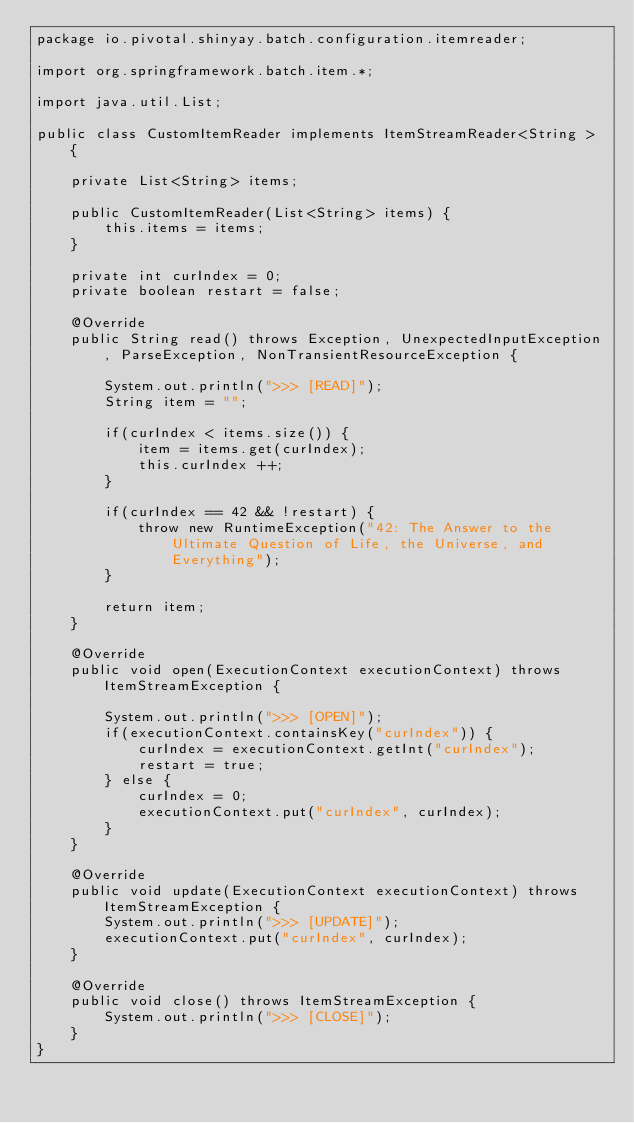<code> <loc_0><loc_0><loc_500><loc_500><_Java_>package io.pivotal.shinyay.batch.configuration.itemreader;

import org.springframework.batch.item.*;

import java.util.List;

public class CustomItemReader implements ItemStreamReader<String > {

    private List<String> items;

    public CustomItemReader(List<String> items) {
        this.items = items;
    }

    private int curIndex = 0;
    private boolean restart = false;

    @Override
    public String read() throws Exception, UnexpectedInputException, ParseException, NonTransientResourceException {

        System.out.println(">>> [READ]");
        String item = "";

        if(curIndex < items.size()) {
            item = items.get(curIndex);
            this.curIndex ++;
        }

        if(curIndex == 42 && !restart) {
            throw new RuntimeException("42: The Answer to the Ultimate Question of Life, the Universe, and Everything");
        }

        return item;
    }

    @Override
    public void open(ExecutionContext executionContext) throws ItemStreamException {

        System.out.println(">>> [OPEN]");
        if(executionContext.containsKey("curIndex")) {
            curIndex = executionContext.getInt("curIndex");
            restart = true;
        } else {
            curIndex = 0;
            executionContext.put("curIndex", curIndex);
        }
    }

    @Override
    public void update(ExecutionContext executionContext) throws ItemStreamException {
        System.out.println(">>> [UPDATE]");
        executionContext.put("curIndex", curIndex);
    }

    @Override
    public void close() throws ItemStreamException {
        System.out.println(">>> [CLOSE]");
    }
}
</code> 